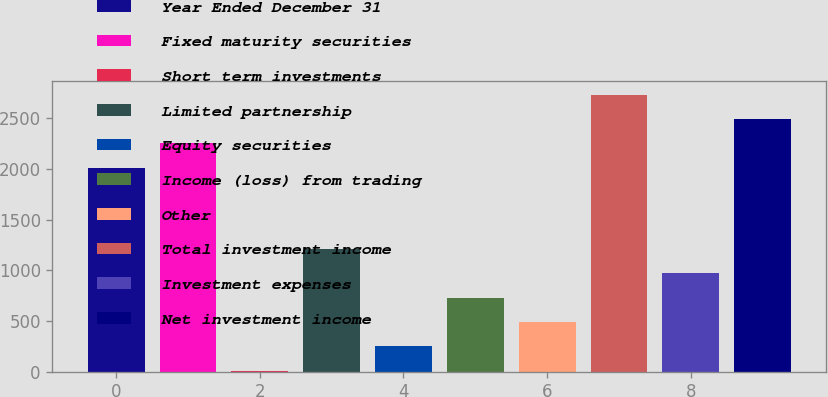<chart> <loc_0><loc_0><loc_500><loc_500><bar_chart><fcel>Year Ended December 31<fcel>Fixed maturity securities<fcel>Short term investments<fcel>Limited partnership<fcel>Equity securities<fcel>Income (loss) from trading<fcel>Other<fcel>Total investment income<fcel>Investment expenses<fcel>Net investment income<nl><fcel>2012<fcel>2251.3<fcel>12<fcel>1208.5<fcel>251.3<fcel>729.9<fcel>490.6<fcel>2729.9<fcel>969.2<fcel>2490.6<nl></chart> 